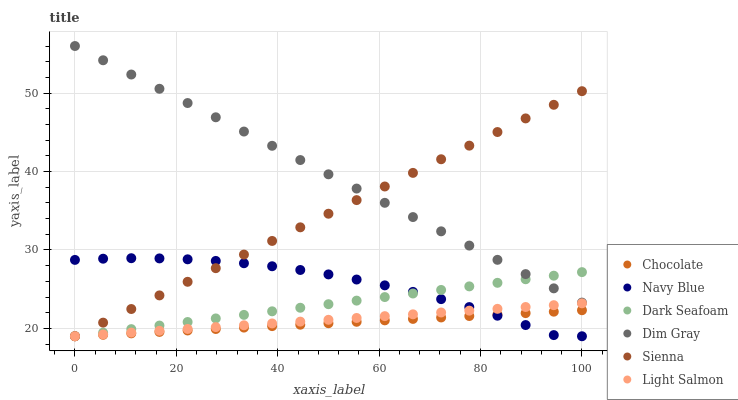Does Chocolate have the minimum area under the curve?
Answer yes or no. Yes. Does Dim Gray have the maximum area under the curve?
Answer yes or no. Yes. Does Navy Blue have the minimum area under the curve?
Answer yes or no. No. Does Navy Blue have the maximum area under the curve?
Answer yes or no. No. Is Dark Seafoam the smoothest?
Answer yes or no. Yes. Is Navy Blue the roughest?
Answer yes or no. Yes. Is Dim Gray the smoothest?
Answer yes or no. No. Is Dim Gray the roughest?
Answer yes or no. No. Does Light Salmon have the lowest value?
Answer yes or no. Yes. Does Dim Gray have the lowest value?
Answer yes or no. No. Does Dim Gray have the highest value?
Answer yes or no. Yes. Does Navy Blue have the highest value?
Answer yes or no. No. Is Chocolate less than Dim Gray?
Answer yes or no. Yes. Is Dim Gray greater than Navy Blue?
Answer yes or no. Yes. Does Sienna intersect Dim Gray?
Answer yes or no. Yes. Is Sienna less than Dim Gray?
Answer yes or no. No. Is Sienna greater than Dim Gray?
Answer yes or no. No. Does Chocolate intersect Dim Gray?
Answer yes or no. No. 